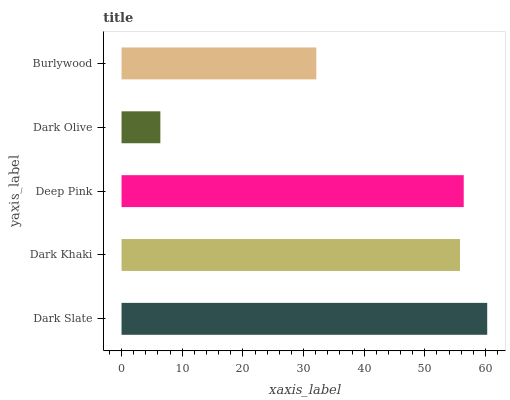Is Dark Olive the minimum?
Answer yes or no. Yes. Is Dark Slate the maximum?
Answer yes or no. Yes. Is Dark Khaki the minimum?
Answer yes or no. No. Is Dark Khaki the maximum?
Answer yes or no. No. Is Dark Slate greater than Dark Khaki?
Answer yes or no. Yes. Is Dark Khaki less than Dark Slate?
Answer yes or no. Yes. Is Dark Khaki greater than Dark Slate?
Answer yes or no. No. Is Dark Slate less than Dark Khaki?
Answer yes or no. No. Is Dark Khaki the high median?
Answer yes or no. Yes. Is Dark Khaki the low median?
Answer yes or no. Yes. Is Dark Olive the high median?
Answer yes or no. No. Is Dark Slate the low median?
Answer yes or no. No. 